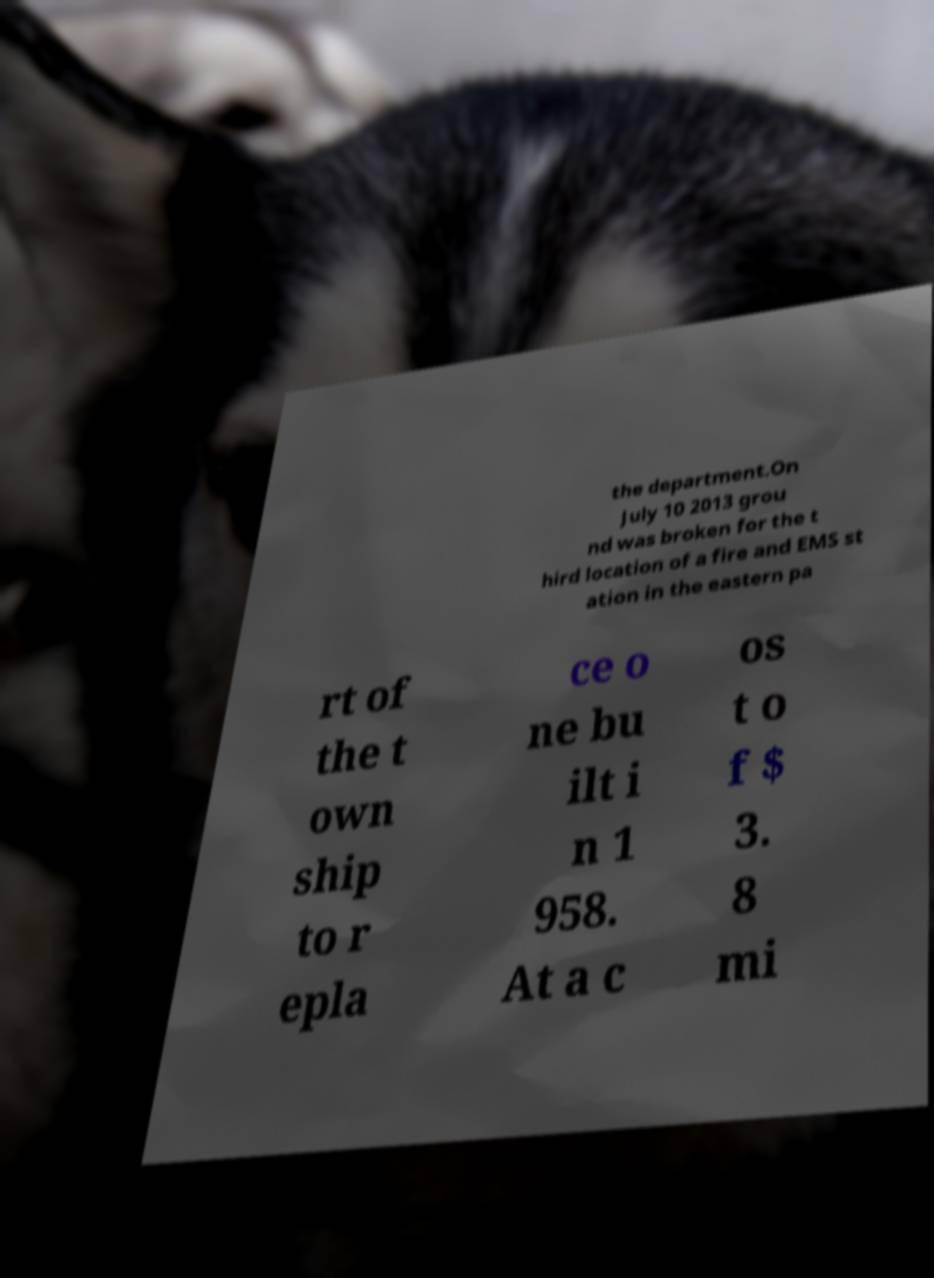Can you read and provide the text displayed in the image?This photo seems to have some interesting text. Can you extract and type it out for me? the department.On July 10 2013 grou nd was broken for the t hird location of a fire and EMS st ation in the eastern pa rt of the t own ship to r epla ce o ne bu ilt i n 1 958. At a c os t o f $ 3. 8 mi 